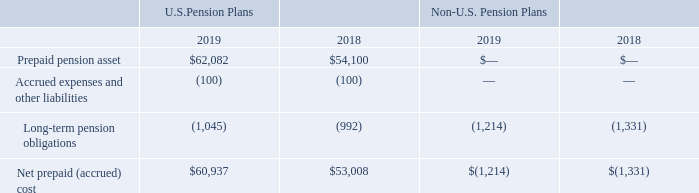NOTES TO CONSOLIDATED FINANCIAL STATEMENTS (in thousands, except for share and per share data)
The components of the prepaid (accrued) cost of the domestic and foreign pension plans are classified in the following lines in the Consolidated Balance Sheets at December 31:
Which years does the table provide information for the components of the prepaid (accrued) cost of the domestic and foreign pension plans ? 2019, 2018. What was the Prepaid pension asset for U.S. Pension Plans in 2018?
Answer scale should be: thousand. 54,100. What was the Long-term pension obligations for Non-U.S. Pension Plans in 2018?
Answer scale should be: thousand. (1,331). What was the change in the Prepaid pension asset for U.S Pension Plans between 2018 and 2019?
Answer scale should be: thousand. 62,082-54,100
Answer: 7982. What was the change in the Net prepaid (accrued) cost for U.S. Pension Plans between 2018 and 2019?
Answer scale should be: thousand. 60,937-53,008
Answer: 7929. What was the percentage change in Long-term pension obligations for U.S. Pension Plans between 2018 and 2019?
Answer scale should be: percent. (-1,045-(992))/-992
Answer: 5.34. 